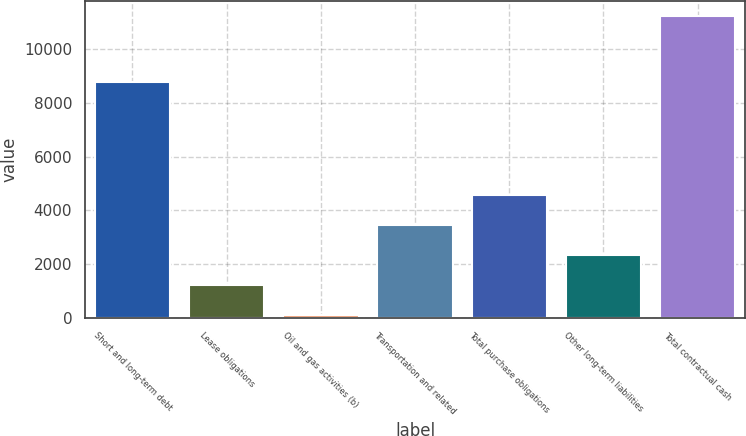Convert chart. <chart><loc_0><loc_0><loc_500><loc_500><bar_chart><fcel>Short and long-term debt<fcel>Lease obligations<fcel>Oil and gas activities (b)<fcel>Transportation and related<fcel>Total purchase obligations<fcel>Other long-term liabilities<fcel>Total contractual cash<nl><fcel>8776<fcel>1222<fcel>108<fcel>3450<fcel>4564<fcel>2336<fcel>11248<nl></chart> 